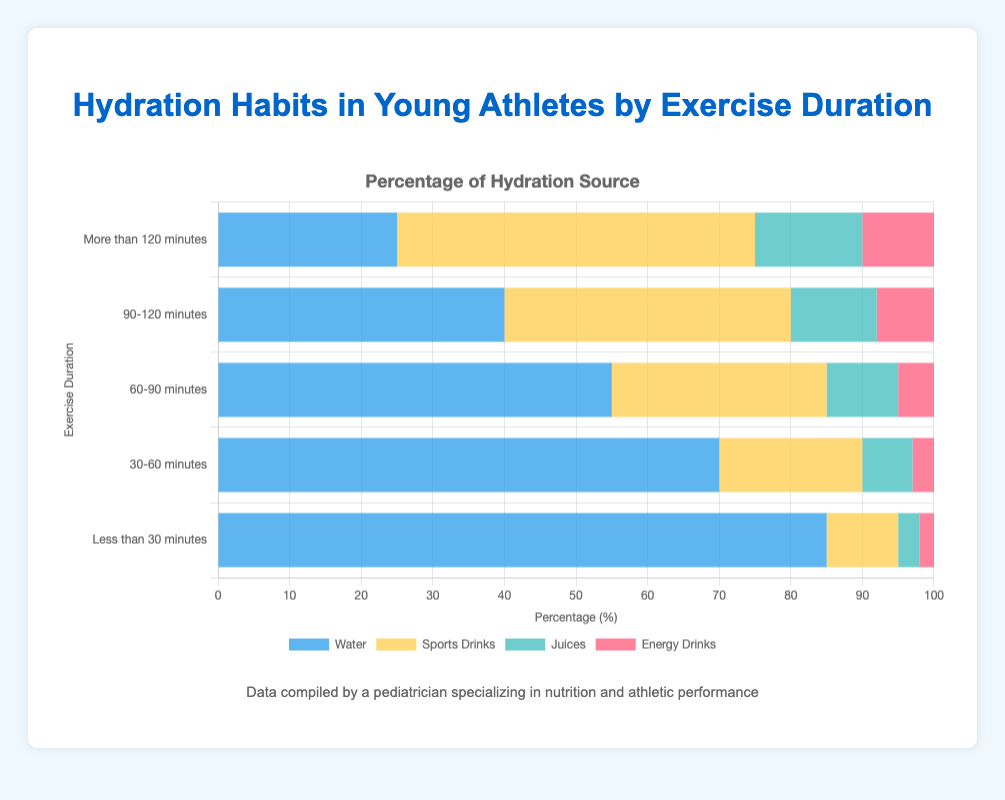What is the most common hydration source for exercises lasting less than 30 minutes? For exercises lasting less than 30 minutes, observe the longest bar in the chart section corresponding to "Less than 30 minutes." The longest bar is for water at 85%.
Answer: Water Which hydration source decreases in percentage as the exercise duration increases? To find out, check each hydration source's percentage from the left (longest duration) to the right (shortest duration). Only water decreases consistently as exercise duration increases from more than 120 minutes to less than 30 minutes.
Answer: Water How do the percentages of sports drinks and water consumed compare for exercises lasting 90-120 minutes? For the duration "90-120 minutes," the percentages are 40% for sports drinks and 40% for water, observed as the lengths of the horizontal bars in that section of the chart. They are equal.
Answer: They are equal What is the total percentage of juices and energy drinks consumed for exercises lasting more than 120 minutes? For the duration "More than 120 minutes," sum the percentages for juices (15%) and energy drinks (10%). 15 + 10 = 25.
Answer: 25% Which hydration source has the smallest change in percentage between exercise durations of 60-90 minutes and 90-120 minutes? Compare the differences in percentages for each hydration source between "60-90 minutes" and "90-120 minutes": Water (55% to 40%: -15), Sports Drinks (30% to 40%: +10), Juices (10% to 12%: +2), Energy Drinks (5% to 8%: +3). Juices have the smallest change of +2%.
Answer: Juices For exercises lasting 30-60 minutes, what is the combined percentage for water and energy drinks? For the duration "30-60 minutes," sum the percentages of water (70%) and energy drinks (3%). 70 + 3 = 73.
Answer: 73% How much more popular are sports drinks compared to juices for exercises lasting more than 120 minutes? For "More than 120 minutes," subtract the juice percentage (15%) from the sports drinks percentage (50%). 50 - 15 = 35.
Answer: 35% Is there a stage where the percentage of energy drinks equals the percentage of juices? If yes, at what duration? Check all durations to see if the percentages for energy drinks and juices match. They do not match for any period in the figure.
Answer: No Which exercise duration category has the highest percentage of sports drink consumption? Find the highest bar for sports drinks across all exercise durations. The highest bar is in "More than 120 minutes," with a sports drink percentage of 50%.
Answer: More than 120 minutes 